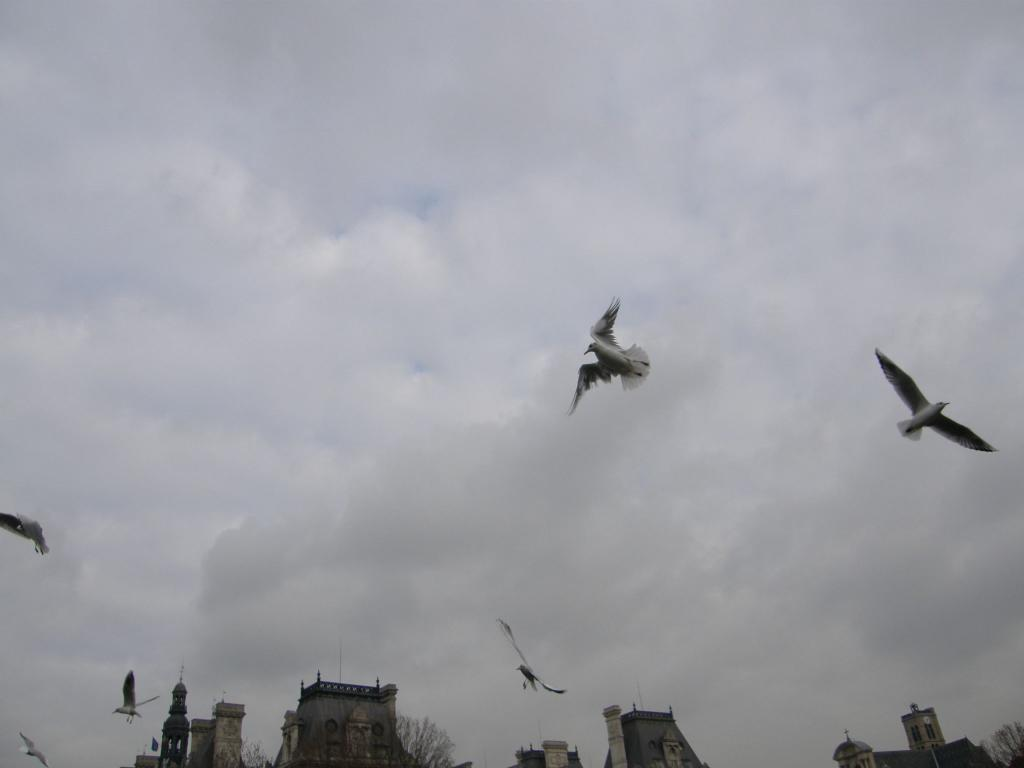What type of structures can be seen in the image? There are buildings in the image. What other natural elements are present in the image? There are trees in the image. What animals can be seen in the image? Birds are flying in the image. What is visible at the top of the image? The sky is visible at the top of the image. What can be observed in the sky? Clouds are present in the sky. Can you see any steam coming from the buildings in the image? There is no steam visible in the image; it only features buildings, trees, birds, and clouds. Is there an ocean visible in the image? There is no ocean present in the image. 